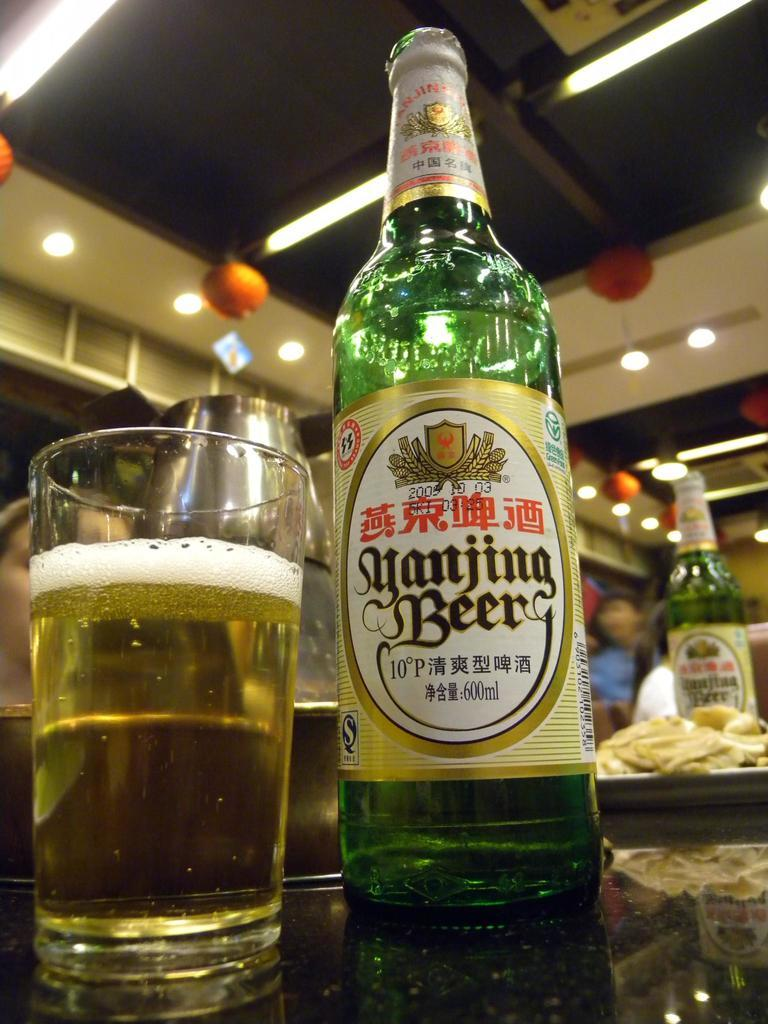Provide a one-sentence caption for the provided image. A bottle of beer is next to a full glass. 